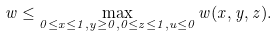Convert formula to latex. <formula><loc_0><loc_0><loc_500><loc_500>w \leq \max _ { 0 \leq x \leq 1 , y \geq 0 , 0 \leq z \leq 1 , u \leq 0 } w ( x , y , z ) .</formula> 